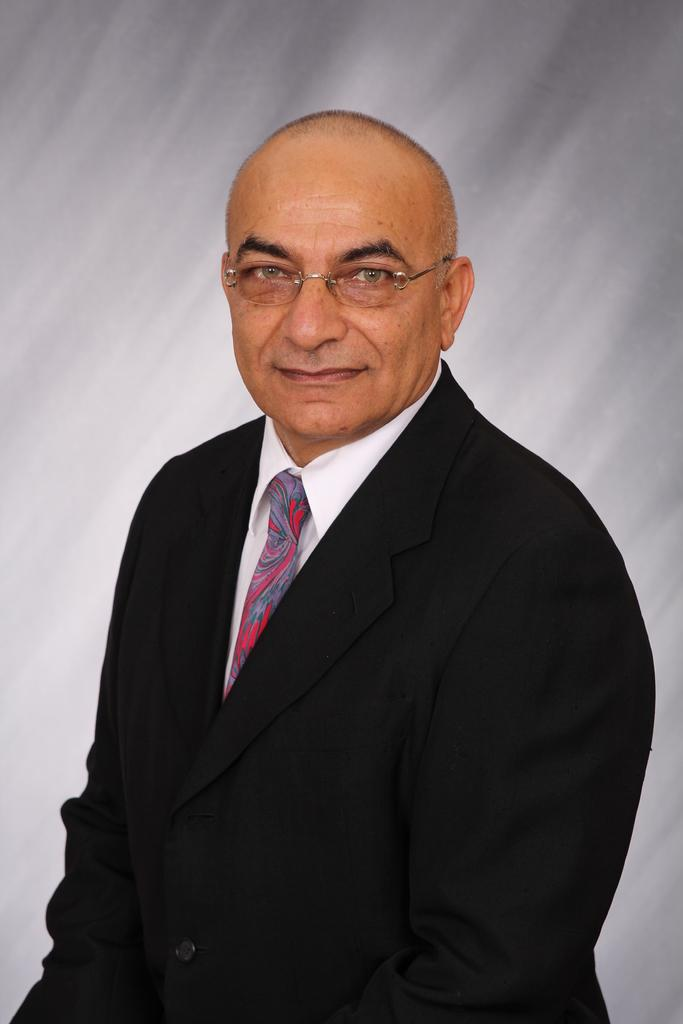What is the main subject of the image? There is a person in the image. What is the person wearing in the image? The person is wearing goggles. How many bananas can be seen in the image? There are no bananas present in the image. What is the man doing in the image? There is no man present in the image, only a person wearing goggles. 